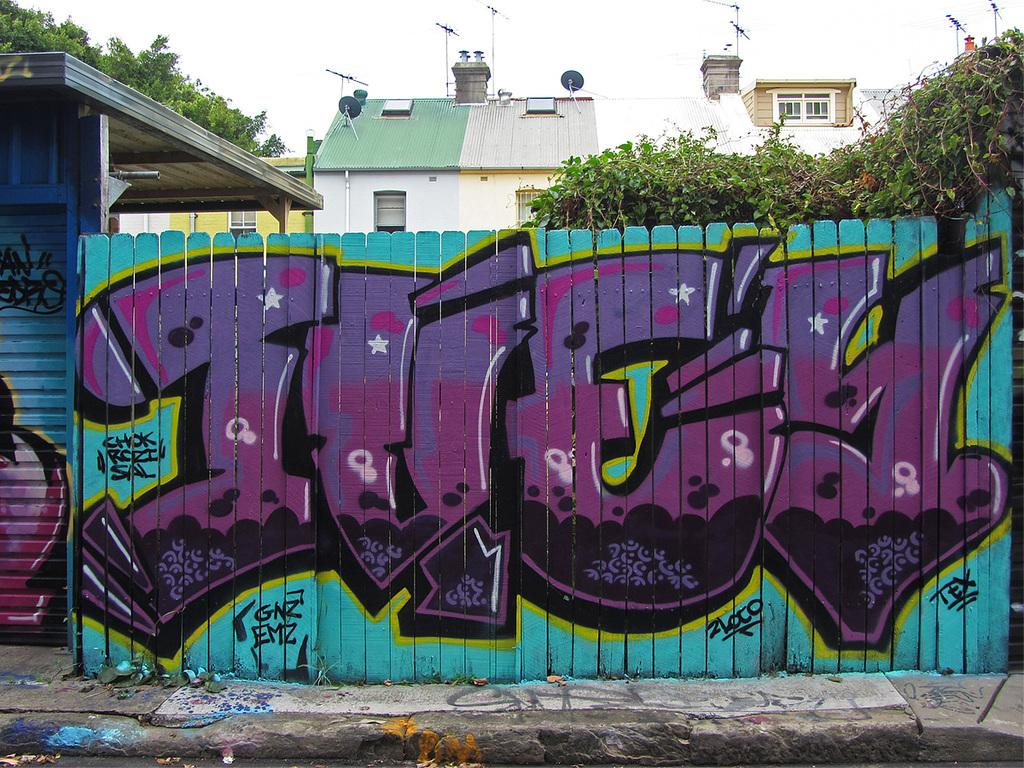What is hanging on the wall in the image? There is a painting on the wall in the image. What can be used to control the amount of light entering a room in the image? There is a shutter in the image. What type of structures can be seen in the image? There are buildings with windows in the image. What type of vegetation is present in the image? There are trees in the image. What is visible in the background of the image? The sky is visible in the background of the image. What type of animal is being used as an ornament in the image? There is no animal being used as an ornament in the image. What selection of items can be seen in the image? The image does not depict a selection of items; it shows a painting, a shutter, buildings, trees, and the sky. 